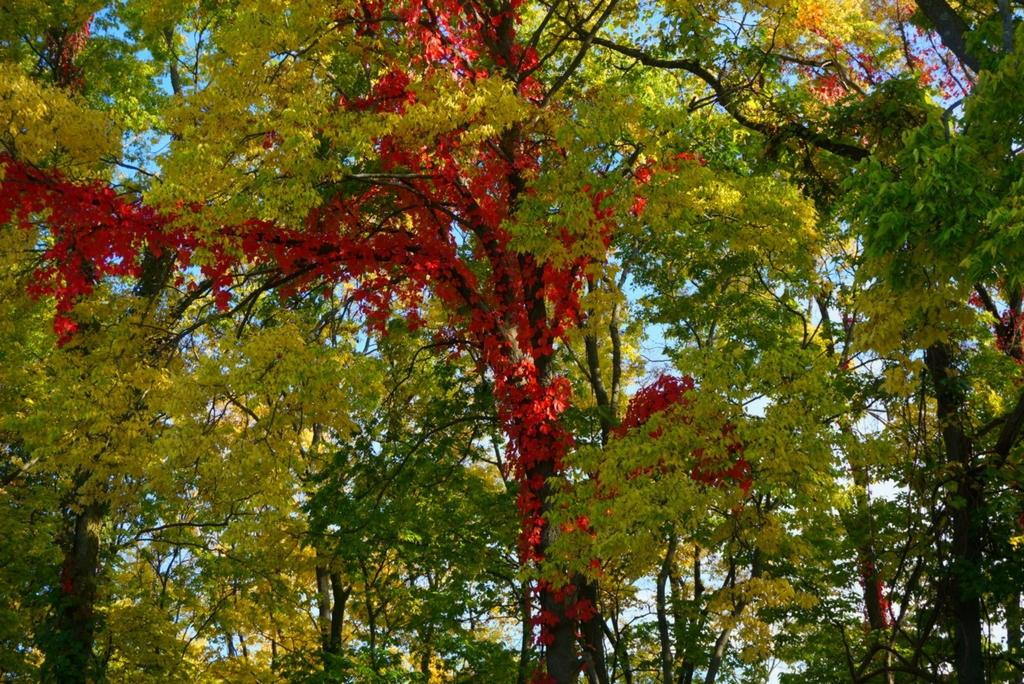What type of vegetation can be seen in the image? There are trees in the image. What part of the natural environment is visible in the image? The sky is visible in the background of the image. Can you see a request form hanging from the trees in the image? There is no request form present in the image; it only features trees and the sky. 